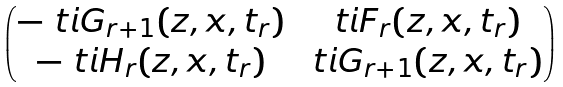Convert formula to latex. <formula><loc_0><loc_0><loc_500><loc_500>\begin{pmatrix} - \ t i { G } _ { r + 1 } ( z , x , t _ { r } ) & \ t i { F } _ { r } ( z , x , t _ { r } ) \\ - \ t i { H } _ { r } ( z , x , t _ { r } ) & \ t i { G } _ { r + 1 } ( z , x , t _ { r } ) \end{pmatrix}</formula> 